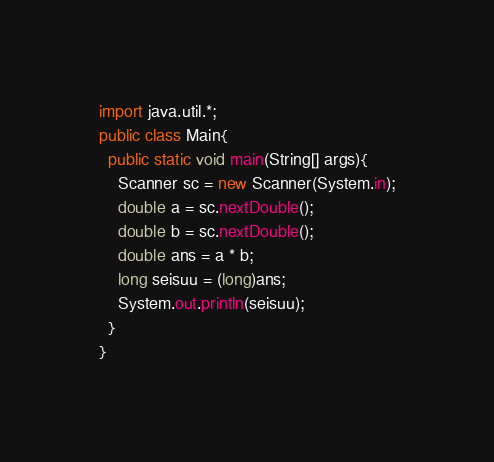<code> <loc_0><loc_0><loc_500><loc_500><_Java_>import java.util.*;
public class Main{
  public static void main(String[] args){
    Scanner sc = new Scanner(System.in);
    double a = sc.nextDouble();
    double b = sc.nextDouble();
    double ans = a * b;
    long seisuu = (long)ans;
    System.out.println(seisuu);
  }
}
</code> 